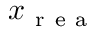Convert formula to latex. <formula><loc_0><loc_0><loc_500><loc_500>x _ { r e a }</formula> 